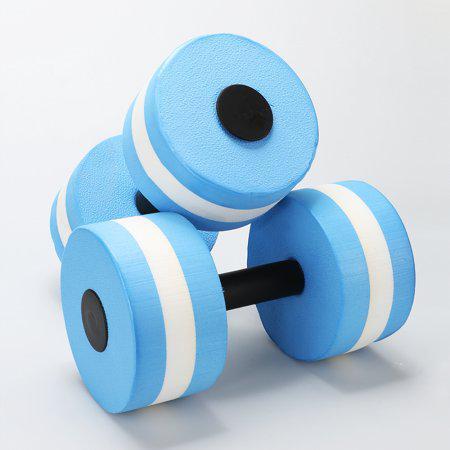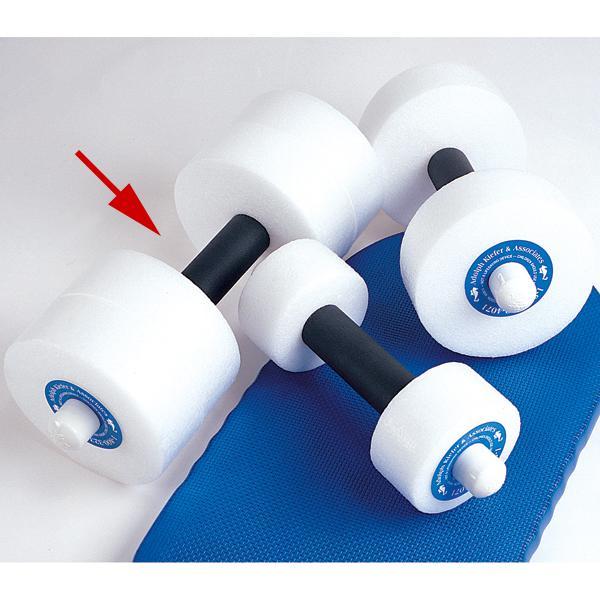The first image is the image on the left, the second image is the image on the right. Assess this claim about the two images: "There are four blue water dumbbell with only two that have white stripes on it.". Correct or not? Answer yes or no. No. The first image is the image on the left, the second image is the image on the right. Analyze the images presented: Is the assertion "Four or fewer dumb bells are visible." valid? Answer yes or no. No. 